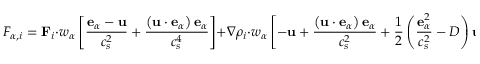Convert formula to latex. <formula><loc_0><loc_0><loc_500><loc_500>F _ { \alpha , i } = F _ { i } \cdot w _ { \alpha } \left [ \frac { e _ { \alpha } - u } { c _ { s } ^ { 2 } } + \frac { \left ( u \cdot e _ { \alpha } \right ) e _ { \alpha } } { c _ { s } ^ { 4 } } \right ] + \nabla \rho _ { i } \cdot w _ { \alpha } \left [ - u + \frac { \left ( u \cdot e _ { \alpha } \right ) e _ { \alpha } } { c _ { s } ^ { 2 } } + \frac { 1 } { 2 } \left ( \frac { e _ { \alpha } ^ { 2 } } { c _ { s } ^ { 2 } } - D \right ) u \right ] ,</formula> 